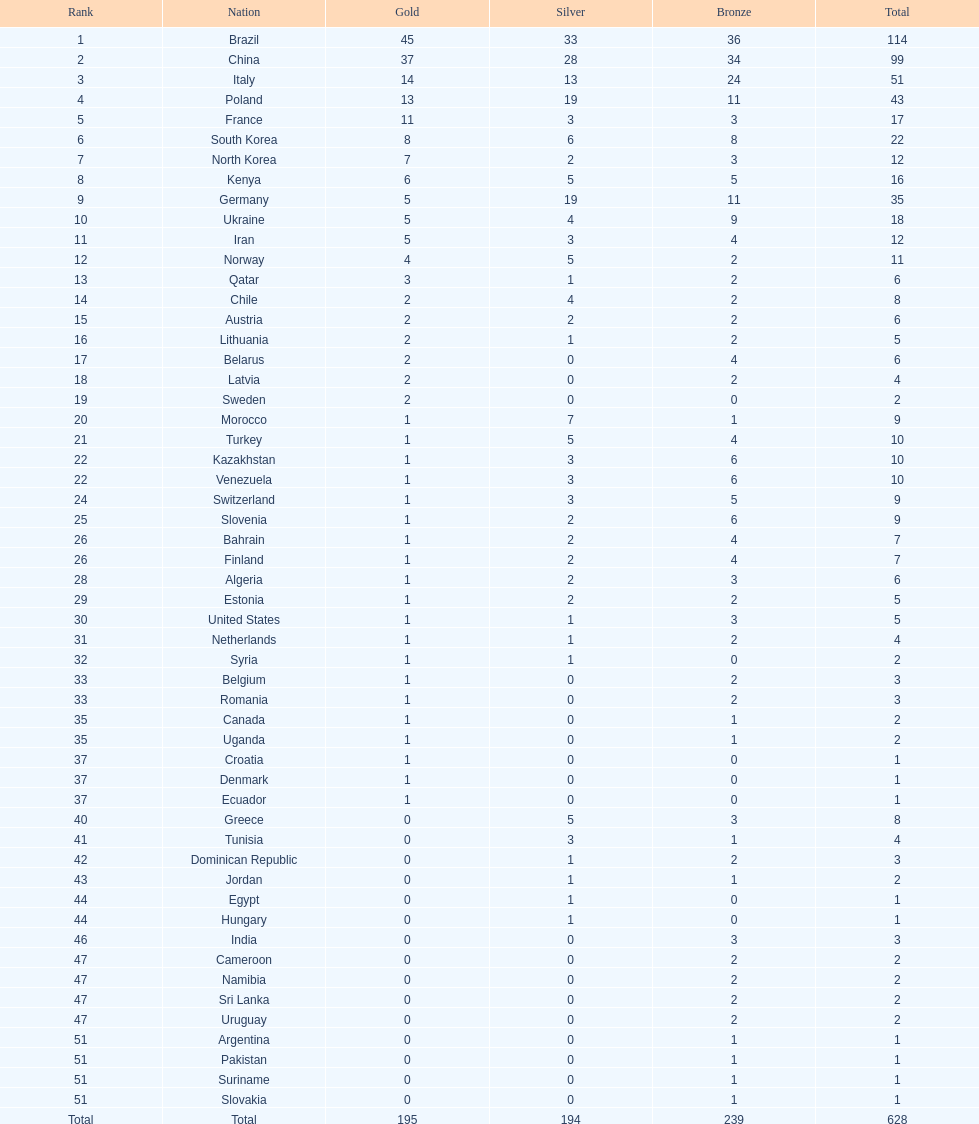How many more gold medals does china have over france? 26. 